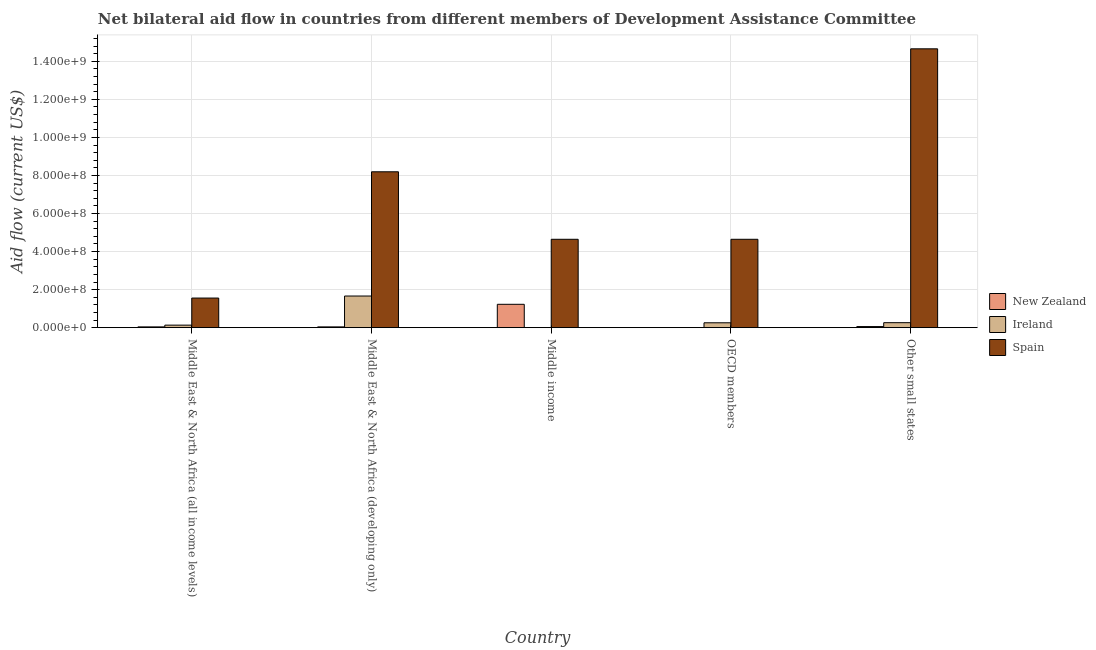How many bars are there on the 2nd tick from the left?
Ensure brevity in your answer.  3. How many bars are there on the 3rd tick from the right?
Give a very brief answer. 3. What is the label of the 2nd group of bars from the left?
Offer a very short reply. Middle East & North Africa (developing only). What is the amount of aid provided by new zealand in Middle East & North Africa (developing only)?
Ensure brevity in your answer.  4.11e+06. Across all countries, what is the maximum amount of aid provided by ireland?
Give a very brief answer. 1.66e+08. Across all countries, what is the minimum amount of aid provided by ireland?
Your answer should be compact. 3.40e+05. In which country was the amount of aid provided by spain maximum?
Make the answer very short. Other small states. What is the total amount of aid provided by ireland in the graph?
Your answer should be very brief. 2.32e+08. What is the difference between the amount of aid provided by ireland in Middle East & North Africa (all income levels) and that in Other small states?
Offer a terse response. -1.28e+07. What is the difference between the amount of aid provided by ireland in OECD members and the amount of aid provided by spain in Other small states?
Your response must be concise. -1.44e+09. What is the average amount of aid provided by ireland per country?
Offer a very short reply. 4.64e+07. What is the difference between the amount of aid provided by spain and amount of aid provided by ireland in Middle income?
Provide a succinct answer. 4.64e+08. In how many countries, is the amount of aid provided by new zealand greater than 1480000000 US$?
Ensure brevity in your answer.  0. What is the ratio of the amount of aid provided by spain in Middle East & North Africa (all income levels) to that in OECD members?
Offer a terse response. 0.33. What is the difference between the highest and the second highest amount of aid provided by ireland?
Give a very brief answer. 1.40e+08. What is the difference between the highest and the lowest amount of aid provided by ireland?
Ensure brevity in your answer.  1.66e+08. What does the 3rd bar from the left in Middle East & North Africa (developing only) represents?
Give a very brief answer. Spain. Is it the case that in every country, the sum of the amount of aid provided by new zealand and amount of aid provided by ireland is greater than the amount of aid provided by spain?
Your answer should be compact. No. Are all the bars in the graph horizontal?
Provide a succinct answer. No. Are the values on the major ticks of Y-axis written in scientific E-notation?
Your response must be concise. Yes. Where does the legend appear in the graph?
Give a very brief answer. Center right. What is the title of the graph?
Make the answer very short. Net bilateral aid flow in countries from different members of Development Assistance Committee. What is the Aid flow (current US$) in New Zealand in Middle East & North Africa (all income levels)?
Make the answer very short. 4.11e+06. What is the Aid flow (current US$) of Ireland in Middle East & North Africa (all income levels)?
Provide a short and direct response. 1.33e+07. What is the Aid flow (current US$) of Spain in Middle East & North Africa (all income levels)?
Ensure brevity in your answer.  1.56e+08. What is the Aid flow (current US$) of New Zealand in Middle East & North Africa (developing only)?
Offer a very short reply. 4.11e+06. What is the Aid flow (current US$) in Ireland in Middle East & North Africa (developing only)?
Ensure brevity in your answer.  1.66e+08. What is the Aid flow (current US$) of Spain in Middle East & North Africa (developing only)?
Your answer should be compact. 8.19e+08. What is the Aid flow (current US$) of New Zealand in Middle income?
Give a very brief answer. 1.23e+08. What is the Aid flow (current US$) of Spain in Middle income?
Your answer should be compact. 4.65e+08. What is the Aid flow (current US$) of Ireland in OECD members?
Offer a very short reply. 2.56e+07. What is the Aid flow (current US$) in Spain in OECD members?
Keep it short and to the point. 4.65e+08. What is the Aid flow (current US$) in New Zealand in Other small states?
Your response must be concise. 5.76e+06. What is the Aid flow (current US$) in Ireland in Other small states?
Make the answer very short. 2.62e+07. What is the Aid flow (current US$) of Spain in Other small states?
Your answer should be very brief. 1.47e+09. Across all countries, what is the maximum Aid flow (current US$) in New Zealand?
Provide a succinct answer. 1.23e+08. Across all countries, what is the maximum Aid flow (current US$) in Ireland?
Provide a succinct answer. 1.66e+08. Across all countries, what is the maximum Aid flow (current US$) in Spain?
Provide a succinct answer. 1.47e+09. Across all countries, what is the minimum Aid flow (current US$) in Ireland?
Make the answer very short. 3.40e+05. Across all countries, what is the minimum Aid flow (current US$) in Spain?
Your answer should be very brief. 1.56e+08. What is the total Aid flow (current US$) of New Zealand in the graph?
Your answer should be compact. 1.37e+08. What is the total Aid flow (current US$) in Ireland in the graph?
Provide a short and direct response. 2.32e+08. What is the total Aid flow (current US$) of Spain in the graph?
Your answer should be compact. 3.37e+09. What is the difference between the Aid flow (current US$) of Ireland in Middle East & North Africa (all income levels) and that in Middle East & North Africa (developing only)?
Give a very brief answer. -1.53e+08. What is the difference between the Aid flow (current US$) in Spain in Middle East & North Africa (all income levels) and that in Middle East & North Africa (developing only)?
Your answer should be compact. -6.64e+08. What is the difference between the Aid flow (current US$) of New Zealand in Middle East & North Africa (all income levels) and that in Middle income?
Make the answer very short. -1.19e+08. What is the difference between the Aid flow (current US$) in Ireland in Middle East & North Africa (all income levels) and that in Middle income?
Your answer should be compact. 1.30e+07. What is the difference between the Aid flow (current US$) of Spain in Middle East & North Africa (all income levels) and that in Middle income?
Provide a succinct answer. -3.09e+08. What is the difference between the Aid flow (current US$) of New Zealand in Middle East & North Africa (all income levels) and that in OECD members?
Provide a short and direct response. 3.67e+06. What is the difference between the Aid flow (current US$) of Ireland in Middle East & North Africa (all income levels) and that in OECD members?
Your answer should be very brief. -1.23e+07. What is the difference between the Aid flow (current US$) in Spain in Middle East & North Africa (all income levels) and that in OECD members?
Provide a succinct answer. -3.09e+08. What is the difference between the Aid flow (current US$) of New Zealand in Middle East & North Africa (all income levels) and that in Other small states?
Offer a terse response. -1.65e+06. What is the difference between the Aid flow (current US$) of Ireland in Middle East & North Africa (all income levels) and that in Other small states?
Offer a very short reply. -1.28e+07. What is the difference between the Aid flow (current US$) of Spain in Middle East & North Africa (all income levels) and that in Other small states?
Your answer should be very brief. -1.31e+09. What is the difference between the Aid flow (current US$) in New Zealand in Middle East & North Africa (developing only) and that in Middle income?
Keep it short and to the point. -1.19e+08. What is the difference between the Aid flow (current US$) of Ireland in Middle East & North Africa (developing only) and that in Middle income?
Your answer should be very brief. 1.66e+08. What is the difference between the Aid flow (current US$) of Spain in Middle East & North Africa (developing only) and that in Middle income?
Your answer should be very brief. 3.55e+08. What is the difference between the Aid flow (current US$) in New Zealand in Middle East & North Africa (developing only) and that in OECD members?
Keep it short and to the point. 3.67e+06. What is the difference between the Aid flow (current US$) in Ireland in Middle East & North Africa (developing only) and that in OECD members?
Offer a very short reply. 1.41e+08. What is the difference between the Aid flow (current US$) of Spain in Middle East & North Africa (developing only) and that in OECD members?
Your answer should be compact. 3.55e+08. What is the difference between the Aid flow (current US$) of New Zealand in Middle East & North Africa (developing only) and that in Other small states?
Make the answer very short. -1.65e+06. What is the difference between the Aid flow (current US$) in Ireland in Middle East & North Africa (developing only) and that in Other small states?
Your response must be concise. 1.40e+08. What is the difference between the Aid flow (current US$) in Spain in Middle East & North Africa (developing only) and that in Other small states?
Give a very brief answer. -6.46e+08. What is the difference between the Aid flow (current US$) in New Zealand in Middle income and that in OECD members?
Your response must be concise. 1.22e+08. What is the difference between the Aid flow (current US$) of Ireland in Middle income and that in OECD members?
Provide a succinct answer. -2.53e+07. What is the difference between the Aid flow (current US$) in New Zealand in Middle income and that in Other small states?
Make the answer very short. 1.17e+08. What is the difference between the Aid flow (current US$) in Ireland in Middle income and that in Other small states?
Your answer should be compact. -2.58e+07. What is the difference between the Aid flow (current US$) of Spain in Middle income and that in Other small states?
Provide a short and direct response. -1.00e+09. What is the difference between the Aid flow (current US$) in New Zealand in OECD members and that in Other small states?
Your response must be concise. -5.32e+06. What is the difference between the Aid flow (current US$) of Ireland in OECD members and that in Other small states?
Provide a succinct answer. -5.60e+05. What is the difference between the Aid flow (current US$) of Spain in OECD members and that in Other small states?
Offer a terse response. -1.00e+09. What is the difference between the Aid flow (current US$) in New Zealand in Middle East & North Africa (all income levels) and the Aid flow (current US$) in Ireland in Middle East & North Africa (developing only)?
Provide a succinct answer. -1.62e+08. What is the difference between the Aid flow (current US$) of New Zealand in Middle East & North Africa (all income levels) and the Aid flow (current US$) of Spain in Middle East & North Africa (developing only)?
Provide a succinct answer. -8.15e+08. What is the difference between the Aid flow (current US$) in Ireland in Middle East & North Africa (all income levels) and the Aid flow (current US$) in Spain in Middle East & North Africa (developing only)?
Your response must be concise. -8.06e+08. What is the difference between the Aid flow (current US$) of New Zealand in Middle East & North Africa (all income levels) and the Aid flow (current US$) of Ireland in Middle income?
Provide a succinct answer. 3.77e+06. What is the difference between the Aid flow (current US$) in New Zealand in Middle East & North Africa (all income levels) and the Aid flow (current US$) in Spain in Middle income?
Your answer should be very brief. -4.60e+08. What is the difference between the Aid flow (current US$) of Ireland in Middle East & North Africa (all income levels) and the Aid flow (current US$) of Spain in Middle income?
Make the answer very short. -4.51e+08. What is the difference between the Aid flow (current US$) in New Zealand in Middle East & North Africa (all income levels) and the Aid flow (current US$) in Ireland in OECD members?
Keep it short and to the point. -2.15e+07. What is the difference between the Aid flow (current US$) in New Zealand in Middle East & North Africa (all income levels) and the Aid flow (current US$) in Spain in OECD members?
Provide a short and direct response. -4.60e+08. What is the difference between the Aid flow (current US$) in Ireland in Middle East & North Africa (all income levels) and the Aid flow (current US$) in Spain in OECD members?
Keep it short and to the point. -4.51e+08. What is the difference between the Aid flow (current US$) of New Zealand in Middle East & North Africa (all income levels) and the Aid flow (current US$) of Ireland in Other small states?
Make the answer very short. -2.21e+07. What is the difference between the Aid flow (current US$) of New Zealand in Middle East & North Africa (all income levels) and the Aid flow (current US$) of Spain in Other small states?
Offer a very short reply. -1.46e+09. What is the difference between the Aid flow (current US$) in Ireland in Middle East & North Africa (all income levels) and the Aid flow (current US$) in Spain in Other small states?
Give a very brief answer. -1.45e+09. What is the difference between the Aid flow (current US$) of New Zealand in Middle East & North Africa (developing only) and the Aid flow (current US$) of Ireland in Middle income?
Ensure brevity in your answer.  3.77e+06. What is the difference between the Aid flow (current US$) of New Zealand in Middle East & North Africa (developing only) and the Aid flow (current US$) of Spain in Middle income?
Give a very brief answer. -4.60e+08. What is the difference between the Aid flow (current US$) in Ireland in Middle East & North Africa (developing only) and the Aid flow (current US$) in Spain in Middle income?
Make the answer very short. -2.98e+08. What is the difference between the Aid flow (current US$) of New Zealand in Middle East & North Africa (developing only) and the Aid flow (current US$) of Ireland in OECD members?
Your answer should be compact. -2.15e+07. What is the difference between the Aid flow (current US$) of New Zealand in Middle East & North Africa (developing only) and the Aid flow (current US$) of Spain in OECD members?
Your answer should be very brief. -4.60e+08. What is the difference between the Aid flow (current US$) in Ireland in Middle East & North Africa (developing only) and the Aid flow (current US$) in Spain in OECD members?
Give a very brief answer. -2.98e+08. What is the difference between the Aid flow (current US$) of New Zealand in Middle East & North Africa (developing only) and the Aid flow (current US$) of Ireland in Other small states?
Offer a very short reply. -2.21e+07. What is the difference between the Aid flow (current US$) of New Zealand in Middle East & North Africa (developing only) and the Aid flow (current US$) of Spain in Other small states?
Provide a short and direct response. -1.46e+09. What is the difference between the Aid flow (current US$) in Ireland in Middle East & North Africa (developing only) and the Aid flow (current US$) in Spain in Other small states?
Provide a short and direct response. -1.30e+09. What is the difference between the Aid flow (current US$) in New Zealand in Middle income and the Aid flow (current US$) in Ireland in OECD members?
Your answer should be very brief. 9.72e+07. What is the difference between the Aid flow (current US$) in New Zealand in Middle income and the Aid flow (current US$) in Spain in OECD members?
Keep it short and to the point. -3.42e+08. What is the difference between the Aid flow (current US$) of Ireland in Middle income and the Aid flow (current US$) of Spain in OECD members?
Keep it short and to the point. -4.64e+08. What is the difference between the Aid flow (current US$) of New Zealand in Middle income and the Aid flow (current US$) of Ireland in Other small states?
Offer a very short reply. 9.66e+07. What is the difference between the Aid flow (current US$) in New Zealand in Middle income and the Aid flow (current US$) in Spain in Other small states?
Give a very brief answer. -1.34e+09. What is the difference between the Aid flow (current US$) in Ireland in Middle income and the Aid flow (current US$) in Spain in Other small states?
Give a very brief answer. -1.47e+09. What is the difference between the Aid flow (current US$) in New Zealand in OECD members and the Aid flow (current US$) in Ireland in Other small states?
Give a very brief answer. -2.58e+07. What is the difference between the Aid flow (current US$) of New Zealand in OECD members and the Aid flow (current US$) of Spain in Other small states?
Make the answer very short. -1.47e+09. What is the difference between the Aid flow (current US$) of Ireland in OECD members and the Aid flow (current US$) of Spain in Other small states?
Offer a terse response. -1.44e+09. What is the average Aid flow (current US$) of New Zealand per country?
Offer a terse response. 2.74e+07. What is the average Aid flow (current US$) of Ireland per country?
Offer a terse response. 4.64e+07. What is the average Aid flow (current US$) of Spain per country?
Make the answer very short. 6.74e+08. What is the difference between the Aid flow (current US$) of New Zealand and Aid flow (current US$) of Ireland in Middle East & North Africa (all income levels)?
Provide a short and direct response. -9.23e+06. What is the difference between the Aid flow (current US$) of New Zealand and Aid flow (current US$) of Spain in Middle East & North Africa (all income levels)?
Provide a short and direct response. -1.52e+08. What is the difference between the Aid flow (current US$) of Ireland and Aid flow (current US$) of Spain in Middle East & North Africa (all income levels)?
Offer a very short reply. -1.42e+08. What is the difference between the Aid flow (current US$) in New Zealand and Aid flow (current US$) in Ireland in Middle East & North Africa (developing only)?
Offer a terse response. -1.62e+08. What is the difference between the Aid flow (current US$) of New Zealand and Aid flow (current US$) of Spain in Middle East & North Africa (developing only)?
Offer a very short reply. -8.15e+08. What is the difference between the Aid flow (current US$) of Ireland and Aid flow (current US$) of Spain in Middle East & North Africa (developing only)?
Ensure brevity in your answer.  -6.53e+08. What is the difference between the Aid flow (current US$) in New Zealand and Aid flow (current US$) in Ireland in Middle income?
Your response must be concise. 1.22e+08. What is the difference between the Aid flow (current US$) in New Zealand and Aid flow (current US$) in Spain in Middle income?
Provide a short and direct response. -3.42e+08. What is the difference between the Aid flow (current US$) in Ireland and Aid flow (current US$) in Spain in Middle income?
Keep it short and to the point. -4.64e+08. What is the difference between the Aid flow (current US$) in New Zealand and Aid flow (current US$) in Ireland in OECD members?
Offer a terse response. -2.52e+07. What is the difference between the Aid flow (current US$) of New Zealand and Aid flow (current US$) of Spain in OECD members?
Ensure brevity in your answer.  -4.64e+08. What is the difference between the Aid flow (current US$) in Ireland and Aid flow (current US$) in Spain in OECD members?
Provide a short and direct response. -4.39e+08. What is the difference between the Aid flow (current US$) in New Zealand and Aid flow (current US$) in Ireland in Other small states?
Your answer should be compact. -2.04e+07. What is the difference between the Aid flow (current US$) of New Zealand and Aid flow (current US$) of Spain in Other small states?
Your answer should be compact. -1.46e+09. What is the difference between the Aid flow (current US$) in Ireland and Aid flow (current US$) in Spain in Other small states?
Your answer should be compact. -1.44e+09. What is the ratio of the Aid flow (current US$) in New Zealand in Middle East & North Africa (all income levels) to that in Middle East & North Africa (developing only)?
Your answer should be very brief. 1. What is the ratio of the Aid flow (current US$) of Ireland in Middle East & North Africa (all income levels) to that in Middle East & North Africa (developing only)?
Your answer should be very brief. 0.08. What is the ratio of the Aid flow (current US$) of Spain in Middle East & North Africa (all income levels) to that in Middle East & North Africa (developing only)?
Ensure brevity in your answer.  0.19. What is the ratio of the Aid flow (current US$) of New Zealand in Middle East & North Africa (all income levels) to that in Middle income?
Offer a terse response. 0.03. What is the ratio of the Aid flow (current US$) of Ireland in Middle East & North Africa (all income levels) to that in Middle income?
Keep it short and to the point. 39.24. What is the ratio of the Aid flow (current US$) of Spain in Middle East & North Africa (all income levels) to that in Middle income?
Make the answer very short. 0.34. What is the ratio of the Aid flow (current US$) in New Zealand in Middle East & North Africa (all income levels) to that in OECD members?
Keep it short and to the point. 9.34. What is the ratio of the Aid flow (current US$) in Ireland in Middle East & North Africa (all income levels) to that in OECD members?
Your answer should be very brief. 0.52. What is the ratio of the Aid flow (current US$) in Spain in Middle East & North Africa (all income levels) to that in OECD members?
Ensure brevity in your answer.  0.34. What is the ratio of the Aid flow (current US$) in New Zealand in Middle East & North Africa (all income levels) to that in Other small states?
Provide a succinct answer. 0.71. What is the ratio of the Aid flow (current US$) of Ireland in Middle East & North Africa (all income levels) to that in Other small states?
Provide a short and direct response. 0.51. What is the ratio of the Aid flow (current US$) of Spain in Middle East & North Africa (all income levels) to that in Other small states?
Your answer should be compact. 0.11. What is the ratio of the Aid flow (current US$) in New Zealand in Middle East & North Africa (developing only) to that in Middle income?
Provide a short and direct response. 0.03. What is the ratio of the Aid flow (current US$) of Ireland in Middle East & North Africa (developing only) to that in Middle income?
Keep it short and to the point. 489.18. What is the ratio of the Aid flow (current US$) of Spain in Middle East & North Africa (developing only) to that in Middle income?
Offer a very short reply. 1.76. What is the ratio of the Aid flow (current US$) of New Zealand in Middle East & North Africa (developing only) to that in OECD members?
Keep it short and to the point. 9.34. What is the ratio of the Aid flow (current US$) in Ireland in Middle East & North Africa (developing only) to that in OECD members?
Keep it short and to the point. 6.49. What is the ratio of the Aid flow (current US$) of Spain in Middle East & North Africa (developing only) to that in OECD members?
Ensure brevity in your answer.  1.76. What is the ratio of the Aid flow (current US$) in New Zealand in Middle East & North Africa (developing only) to that in Other small states?
Provide a succinct answer. 0.71. What is the ratio of the Aid flow (current US$) of Ireland in Middle East & North Africa (developing only) to that in Other small states?
Make the answer very short. 6.35. What is the ratio of the Aid flow (current US$) in Spain in Middle East & North Africa (developing only) to that in Other small states?
Give a very brief answer. 0.56. What is the ratio of the Aid flow (current US$) of New Zealand in Middle income to that in OECD members?
Your response must be concise. 279.16. What is the ratio of the Aid flow (current US$) in Ireland in Middle income to that in OECD members?
Keep it short and to the point. 0.01. What is the ratio of the Aid flow (current US$) of New Zealand in Middle income to that in Other small states?
Your answer should be compact. 21.32. What is the ratio of the Aid flow (current US$) in Ireland in Middle income to that in Other small states?
Offer a terse response. 0.01. What is the ratio of the Aid flow (current US$) of Spain in Middle income to that in Other small states?
Your response must be concise. 0.32. What is the ratio of the Aid flow (current US$) in New Zealand in OECD members to that in Other small states?
Your answer should be very brief. 0.08. What is the ratio of the Aid flow (current US$) of Ireland in OECD members to that in Other small states?
Provide a succinct answer. 0.98. What is the ratio of the Aid flow (current US$) of Spain in OECD members to that in Other small states?
Make the answer very short. 0.32. What is the difference between the highest and the second highest Aid flow (current US$) of New Zealand?
Make the answer very short. 1.17e+08. What is the difference between the highest and the second highest Aid flow (current US$) of Ireland?
Provide a short and direct response. 1.40e+08. What is the difference between the highest and the second highest Aid flow (current US$) of Spain?
Ensure brevity in your answer.  6.46e+08. What is the difference between the highest and the lowest Aid flow (current US$) of New Zealand?
Offer a very short reply. 1.22e+08. What is the difference between the highest and the lowest Aid flow (current US$) of Ireland?
Keep it short and to the point. 1.66e+08. What is the difference between the highest and the lowest Aid flow (current US$) of Spain?
Give a very brief answer. 1.31e+09. 